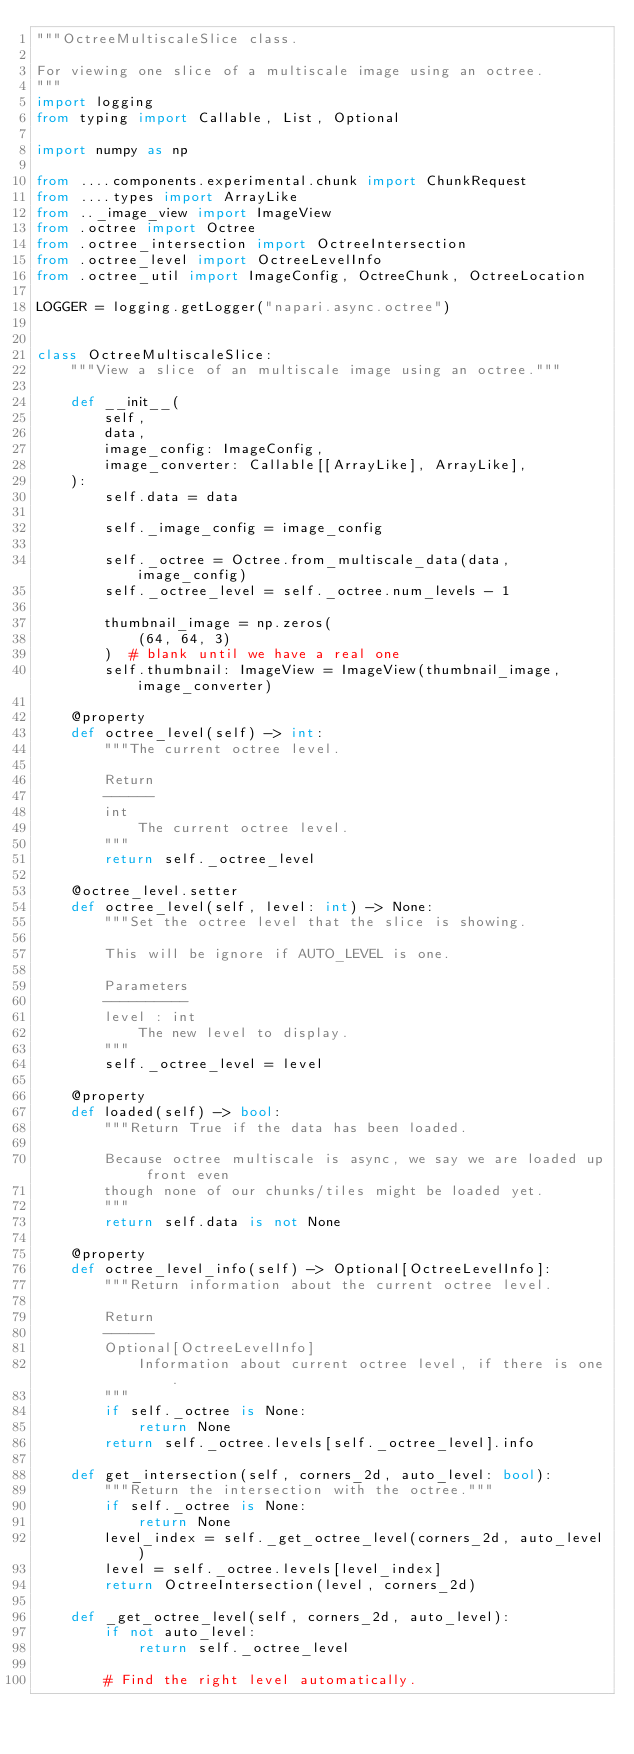<code> <loc_0><loc_0><loc_500><loc_500><_Python_>"""OctreeMultiscaleSlice class.

For viewing one slice of a multiscale image using an octree.
"""
import logging
from typing import Callable, List, Optional

import numpy as np

from ....components.experimental.chunk import ChunkRequest
from ....types import ArrayLike
from .._image_view import ImageView
from .octree import Octree
from .octree_intersection import OctreeIntersection
from .octree_level import OctreeLevelInfo
from .octree_util import ImageConfig, OctreeChunk, OctreeLocation

LOGGER = logging.getLogger("napari.async.octree")


class OctreeMultiscaleSlice:
    """View a slice of an multiscale image using an octree."""

    def __init__(
        self,
        data,
        image_config: ImageConfig,
        image_converter: Callable[[ArrayLike], ArrayLike],
    ):
        self.data = data

        self._image_config = image_config

        self._octree = Octree.from_multiscale_data(data, image_config)
        self._octree_level = self._octree.num_levels - 1

        thumbnail_image = np.zeros(
            (64, 64, 3)
        )  # blank until we have a real one
        self.thumbnail: ImageView = ImageView(thumbnail_image, image_converter)

    @property
    def octree_level(self) -> int:
        """The current octree level.

        Return
        ------
        int
            The current octree level.
        """
        return self._octree_level

    @octree_level.setter
    def octree_level(self, level: int) -> None:
        """Set the octree level that the slice is showing.

        This will be ignore if AUTO_LEVEL is one.

        Parameters
        ----------
        level : int
            The new level to display.
        """
        self._octree_level = level

    @property
    def loaded(self) -> bool:
        """Return True if the data has been loaded.

        Because octree multiscale is async, we say we are loaded up front even
        though none of our chunks/tiles might be loaded yet.
        """
        return self.data is not None

    @property
    def octree_level_info(self) -> Optional[OctreeLevelInfo]:
        """Return information about the current octree level.

        Return
        ------
        Optional[OctreeLevelInfo]
            Information about current octree level, if there is one.
        """
        if self._octree is None:
            return None
        return self._octree.levels[self._octree_level].info

    def get_intersection(self, corners_2d, auto_level: bool):
        """Return the intersection with the octree."""
        if self._octree is None:
            return None
        level_index = self._get_octree_level(corners_2d, auto_level)
        level = self._octree.levels[level_index]
        return OctreeIntersection(level, corners_2d)

    def _get_octree_level(self, corners_2d, auto_level):
        if not auto_level:
            return self._octree_level

        # Find the right level automatically.</code> 